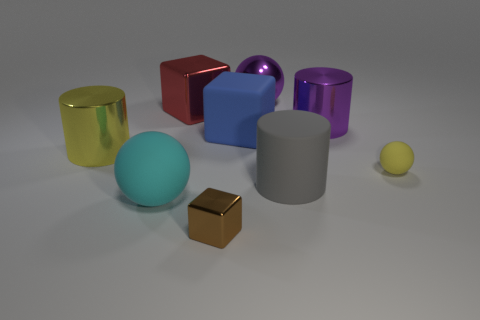Are there an equal number of tiny metal cubes behind the large gray cylinder and purple cubes?
Make the answer very short. Yes. Is the color of the matte cube the same as the big matte cylinder?
Keep it short and to the point. No. There is a small object that is behind the big cyan rubber ball; does it have the same shape as the rubber thing that is on the left side of the large blue rubber cube?
Make the answer very short. Yes. There is a blue object that is the same shape as the brown thing; what is it made of?
Your answer should be very brief. Rubber. There is a ball that is both right of the small brown metallic block and left of the yellow ball; what color is it?
Your response must be concise. Purple. There is a metallic block that is behind the sphere in front of the tiny ball; is there a big blue rubber cube that is in front of it?
Ensure brevity in your answer.  Yes. What number of objects are big green spheres or large things?
Provide a short and direct response. 7. Are the brown object and the large purple thing that is behind the red shiny cube made of the same material?
Provide a succinct answer. Yes. Are there any other things that are the same color as the rubber cylinder?
Offer a very short reply. No. How many things are big shiny objects that are on the right side of the big matte sphere or shiny things to the left of the tiny brown object?
Make the answer very short. 4. 